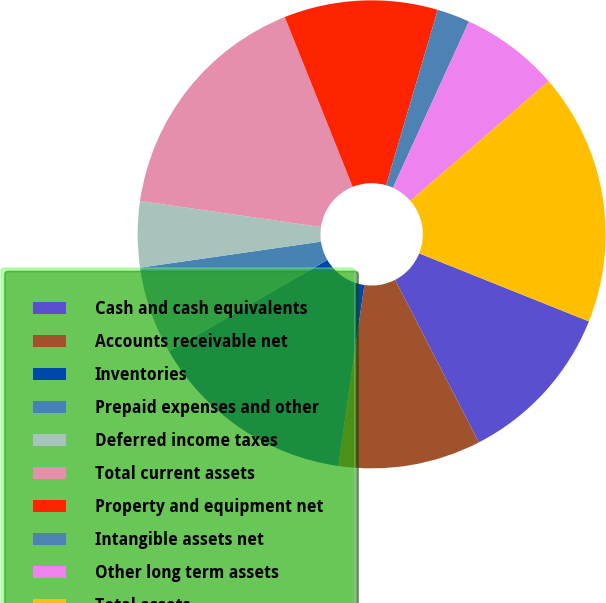Convert chart. <chart><loc_0><loc_0><loc_500><loc_500><pie_chart><fcel>Cash and cash equivalents<fcel>Accounts receivable net<fcel>Inventories<fcel>Prepaid expenses and other<fcel>Deferred income taxes<fcel>Total current assets<fcel>Property and equipment net<fcel>Intangible assets net<fcel>Other long term assets<fcel>Total assets<nl><fcel>11.36%<fcel>9.85%<fcel>14.39%<fcel>6.06%<fcel>4.55%<fcel>16.67%<fcel>10.61%<fcel>2.27%<fcel>6.82%<fcel>17.42%<nl></chart> 